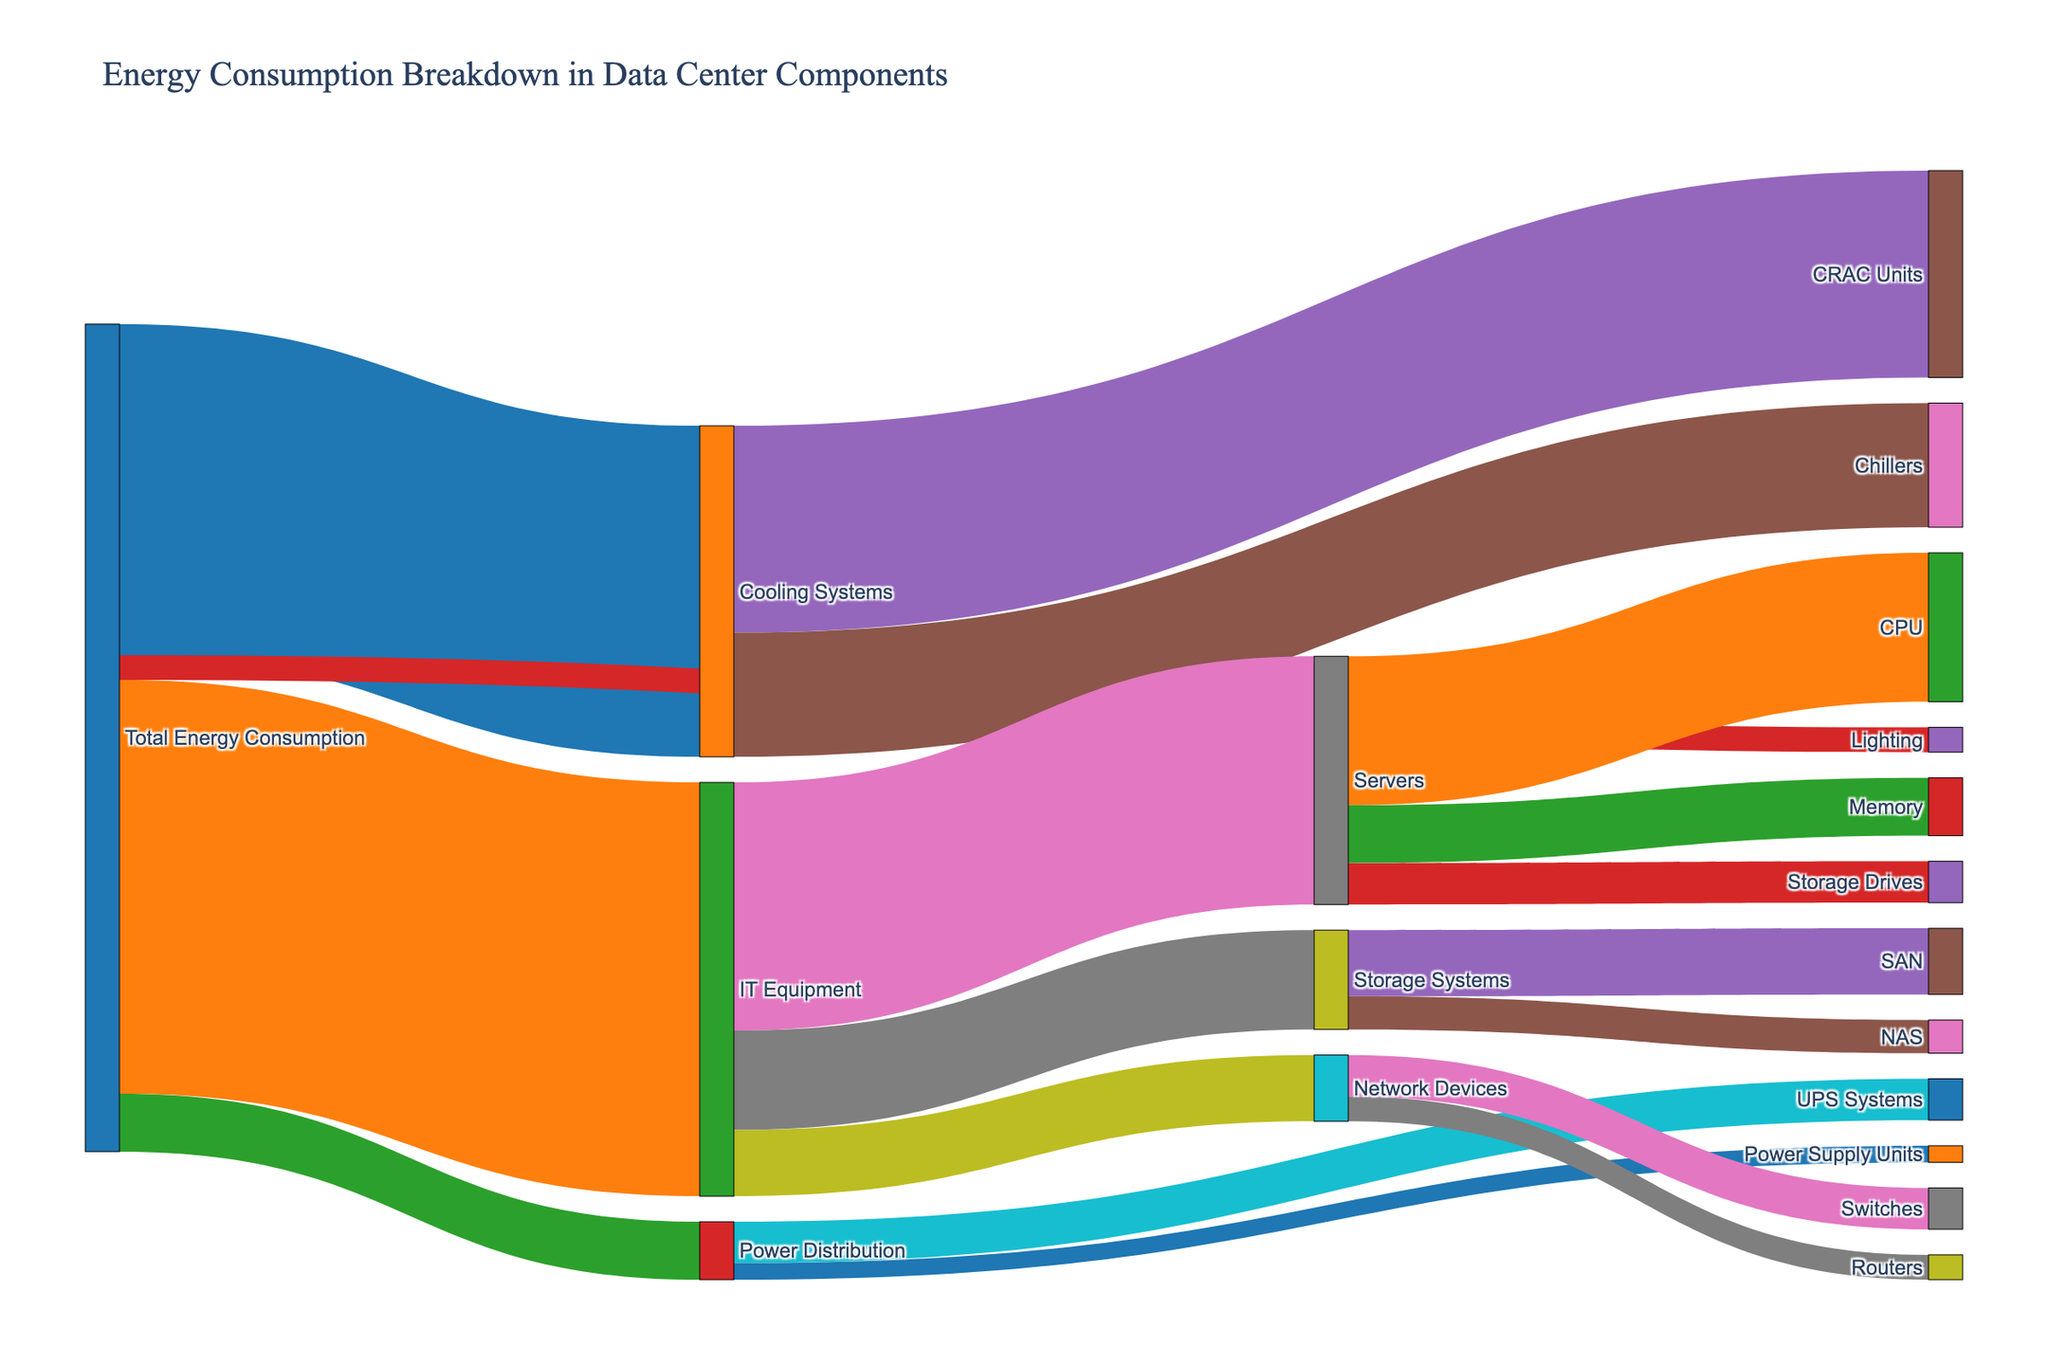What's the main title of the figure? The main title of the figure should appear at the top and be the first thing one notices when looking at the diagram.
Answer: Energy Consumption Breakdown in Data Center Components Which component consumes the most energy from the total energy? The diagram shows several branches from 'Total Energy Consumption'. The one with the largest value represents the component consuming the most energy. According to the figure, IT Equipment has the highest energy consumption value of 50.
Answer: IT Equipment How much energy is consumed by Cooling Systems in percentage terms? The total energy consumption is 100 units. Cooling Systems consume 40 units. To find the percentage, divide the energy consumed by Cooling Systems by the total and multiply by 100. (40/100) * 100 = 40%.
Answer: 40% What's the total energy consumed by Servers? Servers is a subcomponent of IT Equipment. The individual values of energy consumed by different parts of Servers need to be added. These are CPU (18), Memory (7), and Storage Drives (5). Sum them up: 18 + 7 + 5 = 30 units.
Answer: 30 units Which component receives the least energy? The least energy is consumed by Lighting, which is directly seen as only 3 units of energy from 'Total Energy Consumption'.
Answer: Lighting How does the energy consumption of Storage Systems compare to Network Devices? Both are subcomponents of IT Equipment. The energy consumption of Storage Systems is 12 units (SAN of 8 + NAS of 4), while Network Devices consume 8 units (Switches of 5 + Routers of 3). Comparing them, Storage Systems consume more energy.
Answer: Storage Systems consume more energy What percentage of IT Equipment's energy is used by Servers? IT Equipment consumes 50 units of energy. The Servers consume 30 units. To find the percentage, (30/50) * 100 = 60%.
Answer: 60% What is the energy distribution among the subcomponents of Cooling Systems? The subcomponents of Cooling Systems are CRAC Units (25 units) and Chillers (15 units). To get the total for Cooling Systems, they sum to 40 units. The percentages are (25/40) * 100 = 62.5% and (15/40) * 100 = 37.5%.
Answer: CRAC Units: 62.5%, Chillers: 37.5% Compare the energy consumption of CPUs with that of Storage Systems. CPUs consume 18 units and Storage Systems consume 12 units. CPUs consume more energy by a difference of 6 units.
Answer: CPUs consume more 